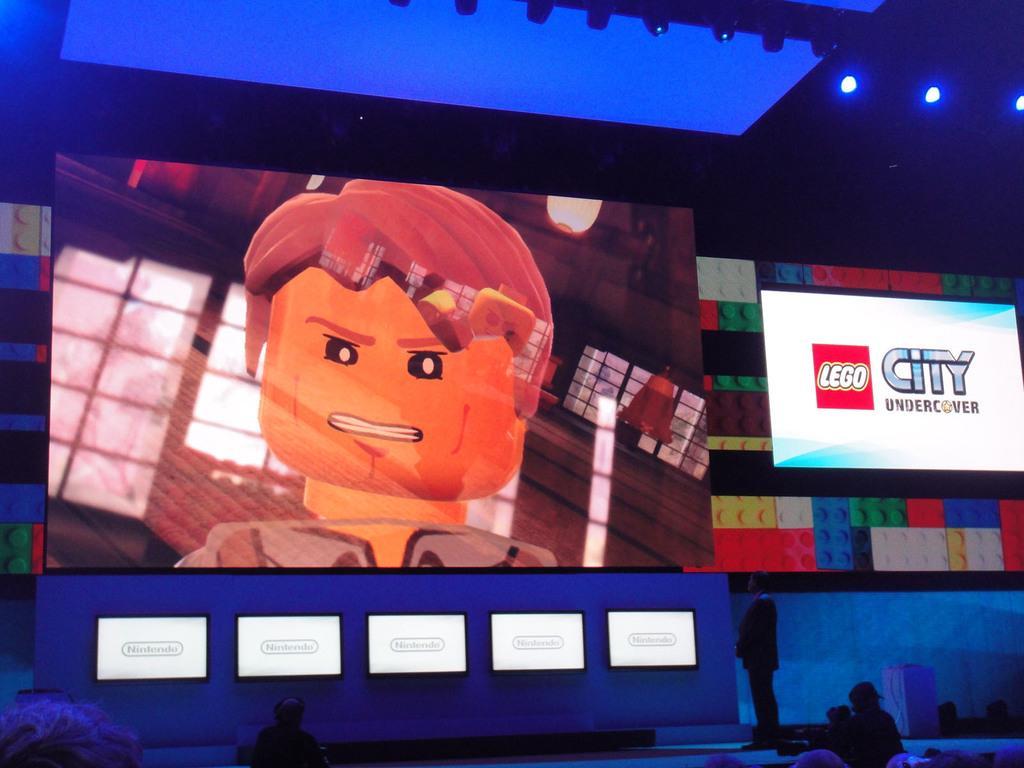Can you describe this image briefly? In this image I see few people in which this person is standing over here and I see screen and I see something is written over here and I see the cartoon character over here and I see the lights on the ceiling and it is dark over here and I see the white screens over here. 